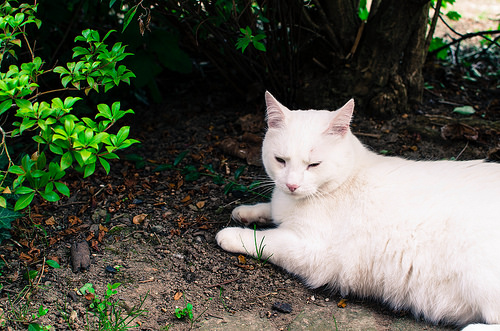<image>
Can you confirm if the cat is on the ground? Yes. Looking at the image, I can see the cat is positioned on top of the ground, with the ground providing support. 